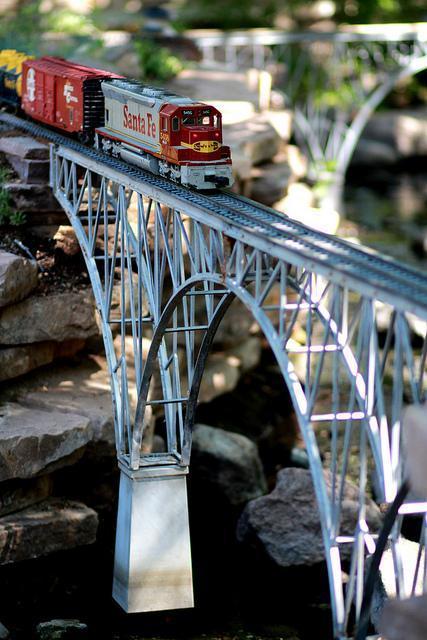How many cars on the train?
Give a very brief answer. 3. 